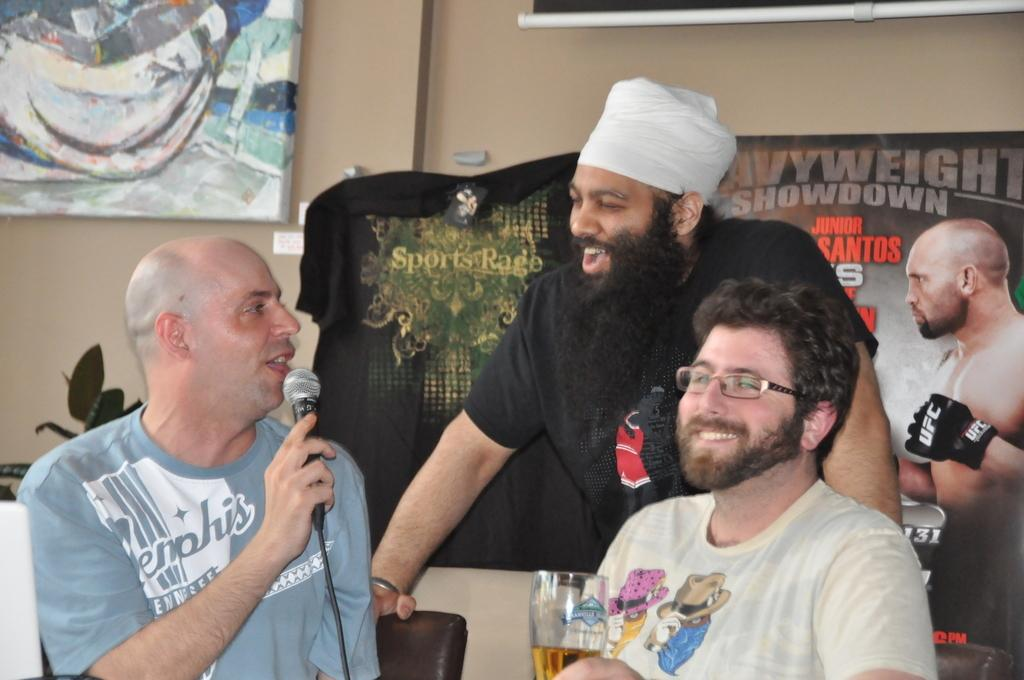How many people are in the image? There are three persons in the image. What are the two people on the left and right sides holding? One person on the left side is holding a mic, and one person on the right side is holding a glass. What can be seen in the background of the image? There is a board visible in the background of the image. What historical event is being discussed by the people in the image? There is no indication of a historical event being discussed in the image. The people are holding a mic and a glass, which suggests they might be participating in a presentation or event, but no specific historical context is provided. 